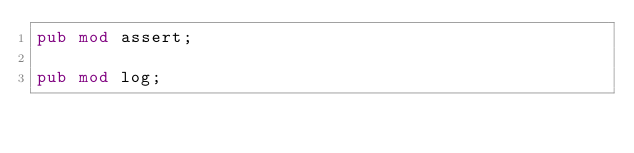<code> <loc_0><loc_0><loc_500><loc_500><_Rust_>pub mod assert;

pub mod log;</code> 